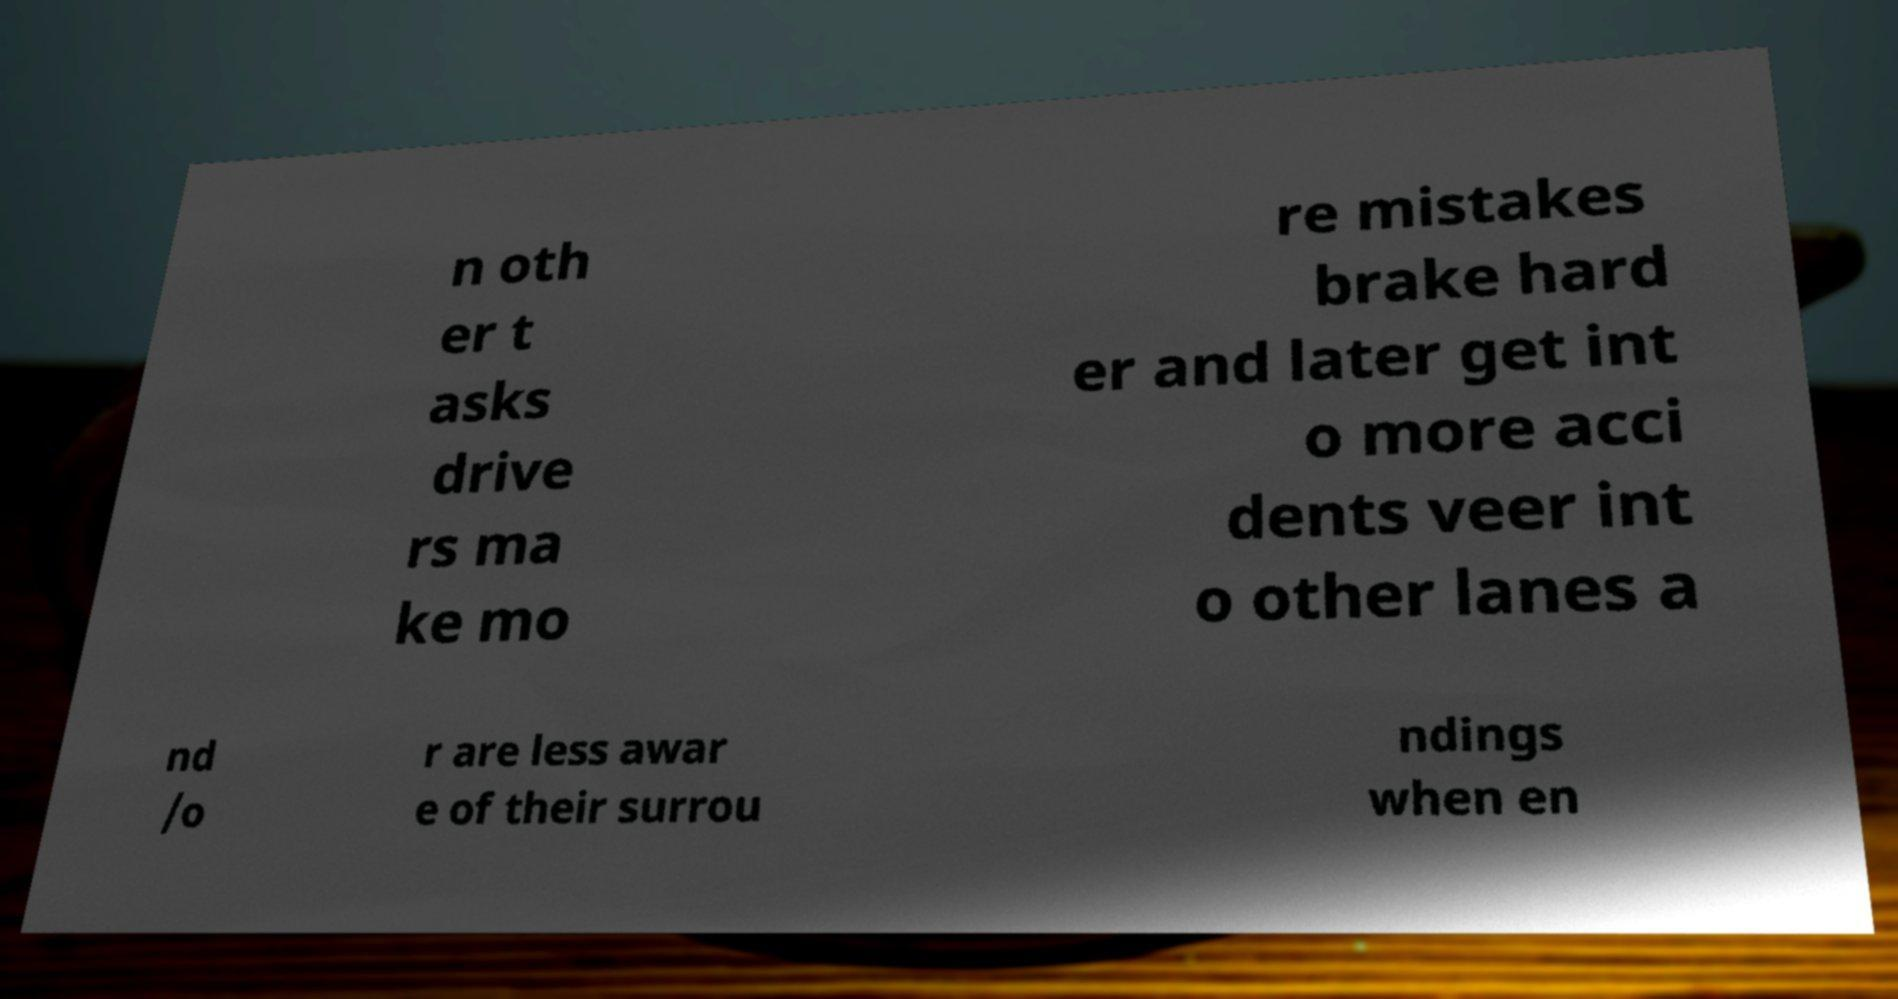Please read and relay the text visible in this image. What does it say? n oth er t asks drive rs ma ke mo re mistakes brake hard er and later get int o more acci dents veer int o other lanes a nd /o r are less awar e of their surrou ndings when en 